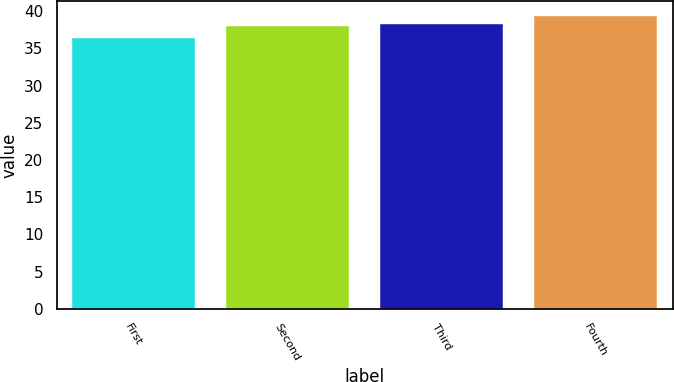Convert chart to OTSL. <chart><loc_0><loc_0><loc_500><loc_500><bar_chart><fcel>First<fcel>Second<fcel>Third<fcel>Fourth<nl><fcel>36.33<fcel>37.95<fcel>38.26<fcel>39.39<nl></chart> 